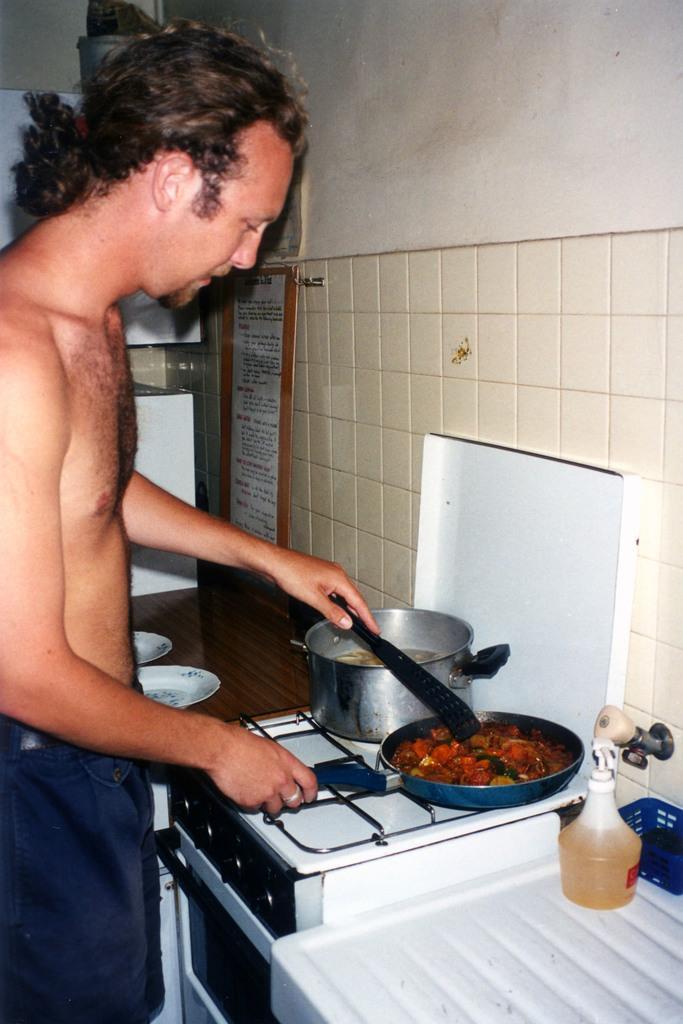Can you describe this image briefly? In this picture there is man standing and holding the pan and spoon. There is food in the pan and in the bowl. There are objects on the table. At the back there are plates and there is an object on the table. There are boards on the wall. There are objects on the top of the cupboard. 